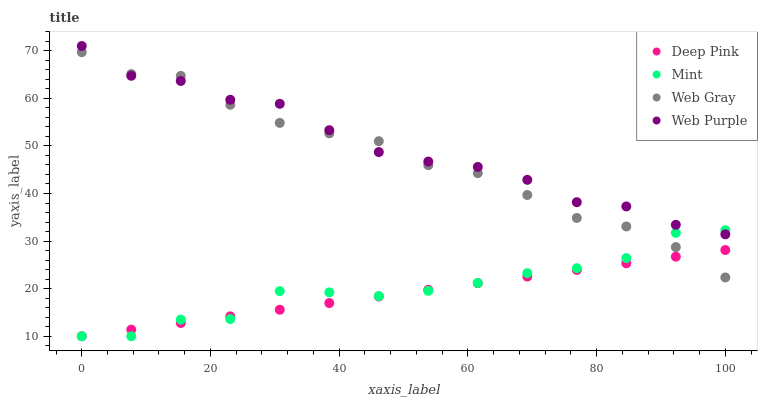Does Deep Pink have the minimum area under the curve?
Answer yes or no. Yes. Does Web Purple have the maximum area under the curve?
Answer yes or no. Yes. Does Web Purple have the minimum area under the curve?
Answer yes or no. No. Does Deep Pink have the maximum area under the curve?
Answer yes or no. No. Is Deep Pink the smoothest?
Answer yes or no. Yes. Is Web Purple the roughest?
Answer yes or no. Yes. Is Web Purple the smoothest?
Answer yes or no. No. Is Deep Pink the roughest?
Answer yes or no. No. Does Deep Pink have the lowest value?
Answer yes or no. Yes. Does Web Purple have the lowest value?
Answer yes or no. No. Does Web Purple have the highest value?
Answer yes or no. Yes. Does Deep Pink have the highest value?
Answer yes or no. No. Is Deep Pink less than Web Purple?
Answer yes or no. Yes. Is Web Purple greater than Deep Pink?
Answer yes or no. Yes. Does Web Gray intersect Deep Pink?
Answer yes or no. Yes. Is Web Gray less than Deep Pink?
Answer yes or no. No. Is Web Gray greater than Deep Pink?
Answer yes or no. No. Does Deep Pink intersect Web Purple?
Answer yes or no. No. 